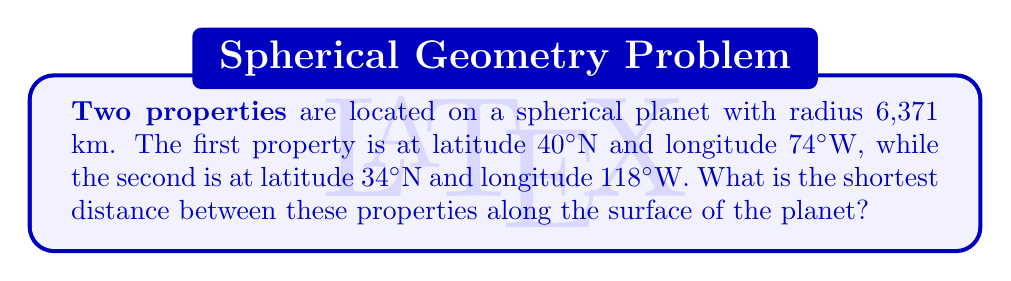Provide a solution to this math problem. To solve this problem, we'll use the great circle distance formula, which gives the shortest path between two points on a sphere. The steps are as follows:

1) Convert the latitudes and longitudes to radians:
   $\phi_1 = 40° \cdot \frac{\pi}{180} = 0.6981$ rad
   $\lambda_1 = -74° \cdot \frac{\pi}{180} = -1.2915$ rad
   $\phi_2 = 34° \cdot \frac{\pi}{180} = 0.5934$ rad
   $\lambda_2 = -118° \cdot \frac{\pi}{180} = -2.0594$ rad

2) Calculate the central angle $\Delta\sigma$ using the Haversine formula:
   $$\Delta\sigma = 2 \arcsin\left(\sqrt{\sin^2\left(\frac{\phi_2-\phi_1}{2}\right) + \cos\phi_1\cos\phi_2\sin^2\left(\frac{\lambda_2-\lambda_1}{2}\right)}\right)$$

3) Substitute the values:
   $$\Delta\sigma = 2 \arcsin\left(\sqrt{\sin^2\left(\frac{0.5934-0.6981}{2}\right) + \cos(0.6981)\cos(0.5934)\sin^2\left(\frac{-2.0594-(-1.2915)}{2}\right)}\right)$$

4) Calculate:
   $$\Delta\sigma = 2 \arcsin(\sqrt{0.0014 + 0.5736}) = 2 \arcsin(0.7608) = 0.6696$$

5) The distance $d$ is then given by:
   $$d = R \cdot \Delta\sigma$$
   where $R$ is the radius of the planet.

6) Substitute $R = 6,371$ km:
   $$d = 6,371 \cdot 0.6696 = 4,266.02 \text{ km}$$

Therefore, the shortest distance between the two properties is approximately 4,266.02 km.
Answer: 4,266.02 km 